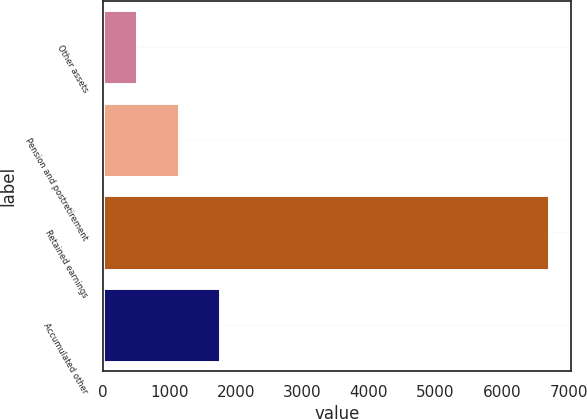Convert chart to OTSL. <chart><loc_0><loc_0><loc_500><loc_500><bar_chart><fcel>Other assets<fcel>Pension and postretirement<fcel>Retained earnings<fcel>Accumulated other<nl><fcel>522.3<fcel>1140.65<fcel>6705.8<fcel>1759<nl></chart> 